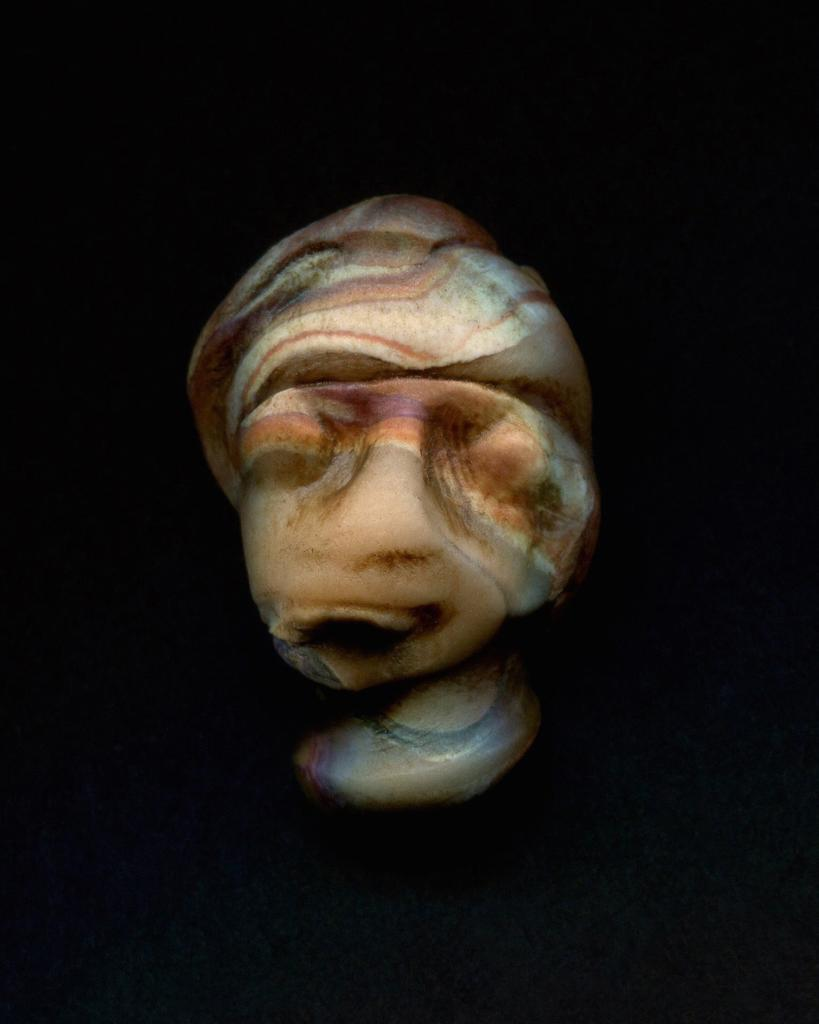What is the main subject of the image? There is a sculpture in the image. How is the sculpture decorated? The sculpture has colorful paints on it. What is the color of the background in the image? The background of the image is black. Can you tell me what type of watch is on the sculpture in the image? There is no watch present on the sculpture in the image. What kind of insect can be seen crawling on the sculpture in the image? There are no insects visible on the sculpture in the image. 